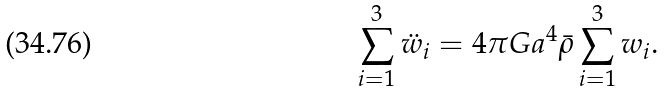<formula> <loc_0><loc_0><loc_500><loc_500>\sum _ { i = 1 } ^ { 3 } \ddot { w } _ { i } = 4 \pi G a ^ { 4 } \bar { \rho } \sum _ { i = 1 } ^ { 3 } w _ { i } .</formula> 